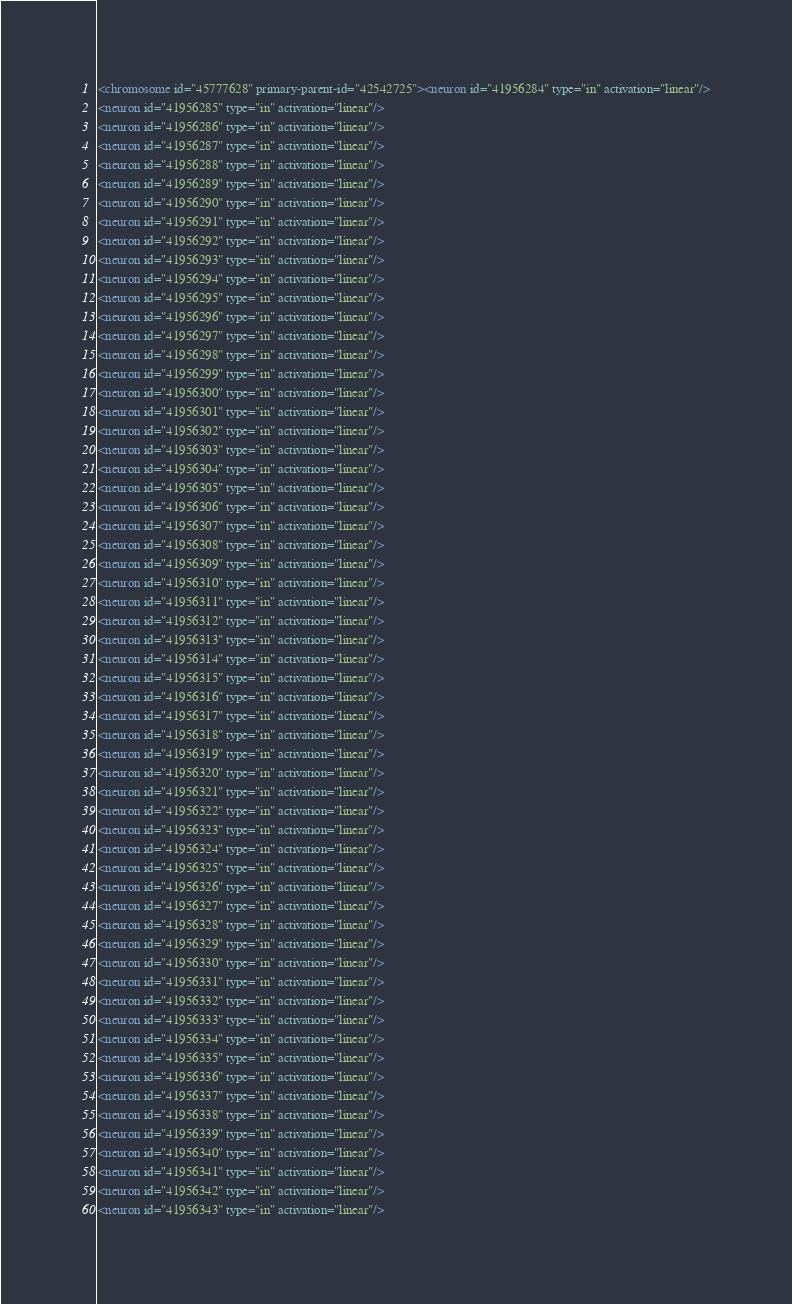Convert code to text. <code><loc_0><loc_0><loc_500><loc_500><_XML_><chromosome id="45777628" primary-parent-id="42542725"><neuron id="41956284" type="in" activation="linear"/>
<neuron id="41956285" type="in" activation="linear"/>
<neuron id="41956286" type="in" activation="linear"/>
<neuron id="41956287" type="in" activation="linear"/>
<neuron id="41956288" type="in" activation="linear"/>
<neuron id="41956289" type="in" activation="linear"/>
<neuron id="41956290" type="in" activation="linear"/>
<neuron id="41956291" type="in" activation="linear"/>
<neuron id="41956292" type="in" activation="linear"/>
<neuron id="41956293" type="in" activation="linear"/>
<neuron id="41956294" type="in" activation="linear"/>
<neuron id="41956295" type="in" activation="linear"/>
<neuron id="41956296" type="in" activation="linear"/>
<neuron id="41956297" type="in" activation="linear"/>
<neuron id="41956298" type="in" activation="linear"/>
<neuron id="41956299" type="in" activation="linear"/>
<neuron id="41956300" type="in" activation="linear"/>
<neuron id="41956301" type="in" activation="linear"/>
<neuron id="41956302" type="in" activation="linear"/>
<neuron id="41956303" type="in" activation="linear"/>
<neuron id="41956304" type="in" activation="linear"/>
<neuron id="41956305" type="in" activation="linear"/>
<neuron id="41956306" type="in" activation="linear"/>
<neuron id="41956307" type="in" activation="linear"/>
<neuron id="41956308" type="in" activation="linear"/>
<neuron id="41956309" type="in" activation="linear"/>
<neuron id="41956310" type="in" activation="linear"/>
<neuron id="41956311" type="in" activation="linear"/>
<neuron id="41956312" type="in" activation="linear"/>
<neuron id="41956313" type="in" activation="linear"/>
<neuron id="41956314" type="in" activation="linear"/>
<neuron id="41956315" type="in" activation="linear"/>
<neuron id="41956316" type="in" activation="linear"/>
<neuron id="41956317" type="in" activation="linear"/>
<neuron id="41956318" type="in" activation="linear"/>
<neuron id="41956319" type="in" activation="linear"/>
<neuron id="41956320" type="in" activation="linear"/>
<neuron id="41956321" type="in" activation="linear"/>
<neuron id="41956322" type="in" activation="linear"/>
<neuron id="41956323" type="in" activation="linear"/>
<neuron id="41956324" type="in" activation="linear"/>
<neuron id="41956325" type="in" activation="linear"/>
<neuron id="41956326" type="in" activation="linear"/>
<neuron id="41956327" type="in" activation="linear"/>
<neuron id="41956328" type="in" activation="linear"/>
<neuron id="41956329" type="in" activation="linear"/>
<neuron id="41956330" type="in" activation="linear"/>
<neuron id="41956331" type="in" activation="linear"/>
<neuron id="41956332" type="in" activation="linear"/>
<neuron id="41956333" type="in" activation="linear"/>
<neuron id="41956334" type="in" activation="linear"/>
<neuron id="41956335" type="in" activation="linear"/>
<neuron id="41956336" type="in" activation="linear"/>
<neuron id="41956337" type="in" activation="linear"/>
<neuron id="41956338" type="in" activation="linear"/>
<neuron id="41956339" type="in" activation="linear"/>
<neuron id="41956340" type="in" activation="linear"/>
<neuron id="41956341" type="in" activation="linear"/>
<neuron id="41956342" type="in" activation="linear"/>
<neuron id="41956343" type="in" activation="linear"/></code> 